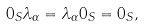<formula> <loc_0><loc_0><loc_500><loc_500>0 _ { S } \lambda _ { \alpha } = \lambda _ { \alpha } 0 _ { S } = 0 _ { S } ,</formula> 